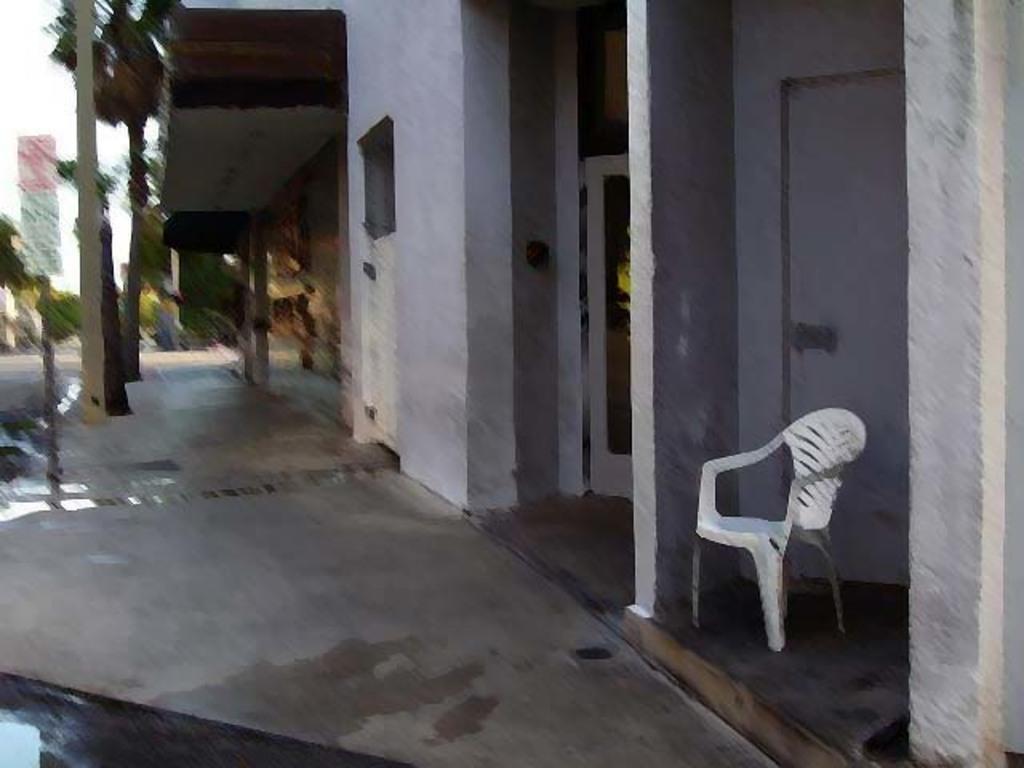Please provide a concise description of this image. This picture is slightly blurred, where we can see a chair, I can see pillars, buildings, boards, trees and the sky in the background. 